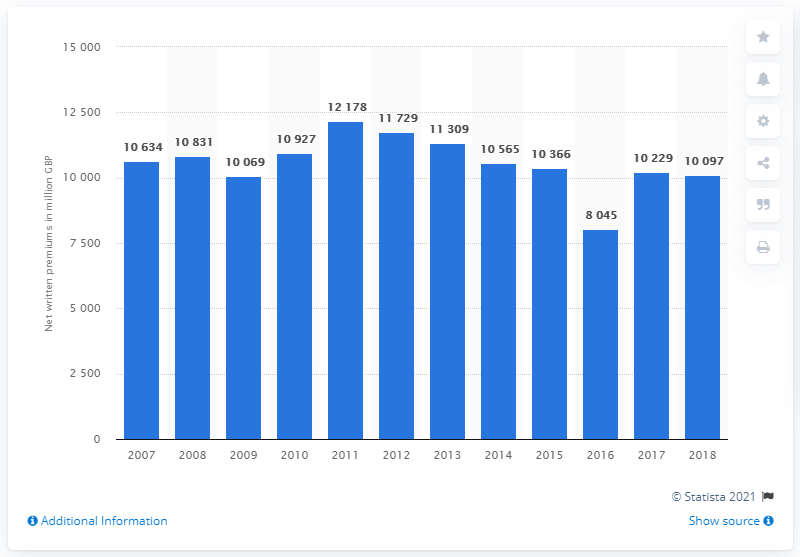Highlight a few significant elements in this photo. The net written premiums for motor insurance in the UK in 2018 were approximately 10,097. 